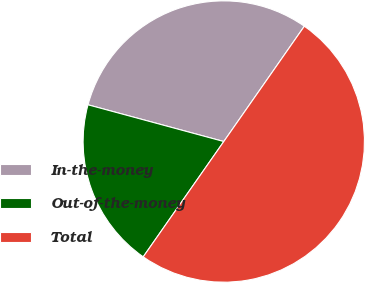Convert chart. <chart><loc_0><loc_0><loc_500><loc_500><pie_chart><fcel>In-the-money<fcel>Out-of-the-money<fcel>Total<nl><fcel>30.5%<fcel>19.5%<fcel>50.0%<nl></chart> 